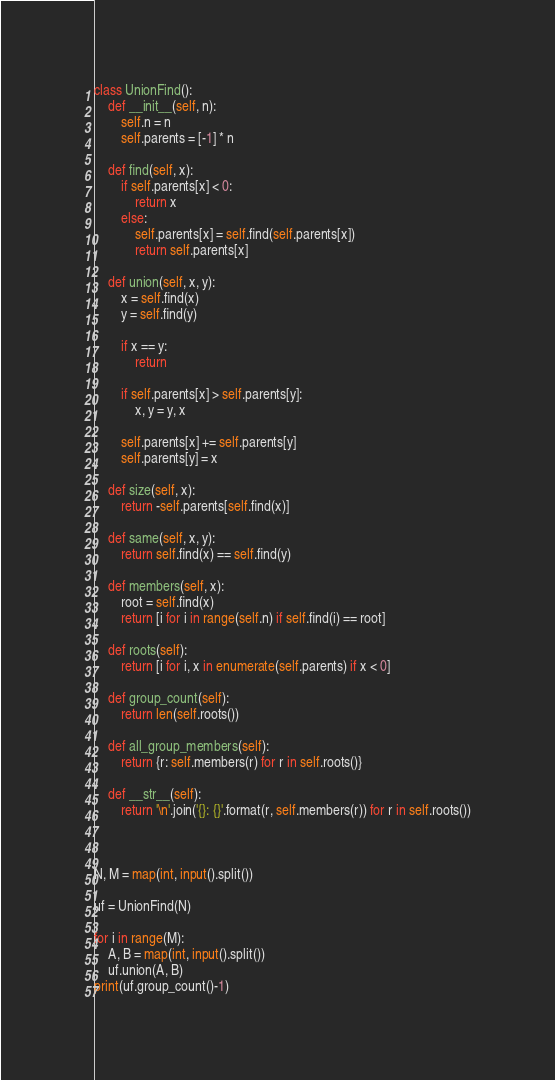Convert code to text. <code><loc_0><loc_0><loc_500><loc_500><_Python_>class UnionFind():
    def __init__(self, n):
        self.n = n
        self.parents = [-1] * n

    def find(self, x):
        if self.parents[x] < 0:
            return x
        else:
            self.parents[x] = self.find(self.parents[x])
            return self.parents[x]

    def union(self, x, y):
        x = self.find(x)
        y = self.find(y)

        if x == y:
            return

        if self.parents[x] > self.parents[y]:
            x, y = y, x

        self.parents[x] += self.parents[y]
        self.parents[y] = x

    def size(self, x):
        return -self.parents[self.find(x)]

    def same(self, x, y):
        return self.find(x) == self.find(y)

    def members(self, x):
        root = self.find(x)
        return [i for i in range(self.n) if self.find(i) == root]

    def roots(self):
        return [i for i, x in enumerate(self.parents) if x < 0]

    def group_count(self):
        return len(self.roots())

    def all_group_members(self):
        return {r: self.members(r) for r in self.roots()}

    def __str__(self):
        return '\n'.join('{}: {}'.format(r, self.members(r)) for r in self.roots())



N, M = map(int, input().split())
 
uf = UnionFind(N)
 
for i in range(M):
    A, B = map(int, input().split())
    uf.union(A, B)
print(uf.group_count()-1)
</code> 